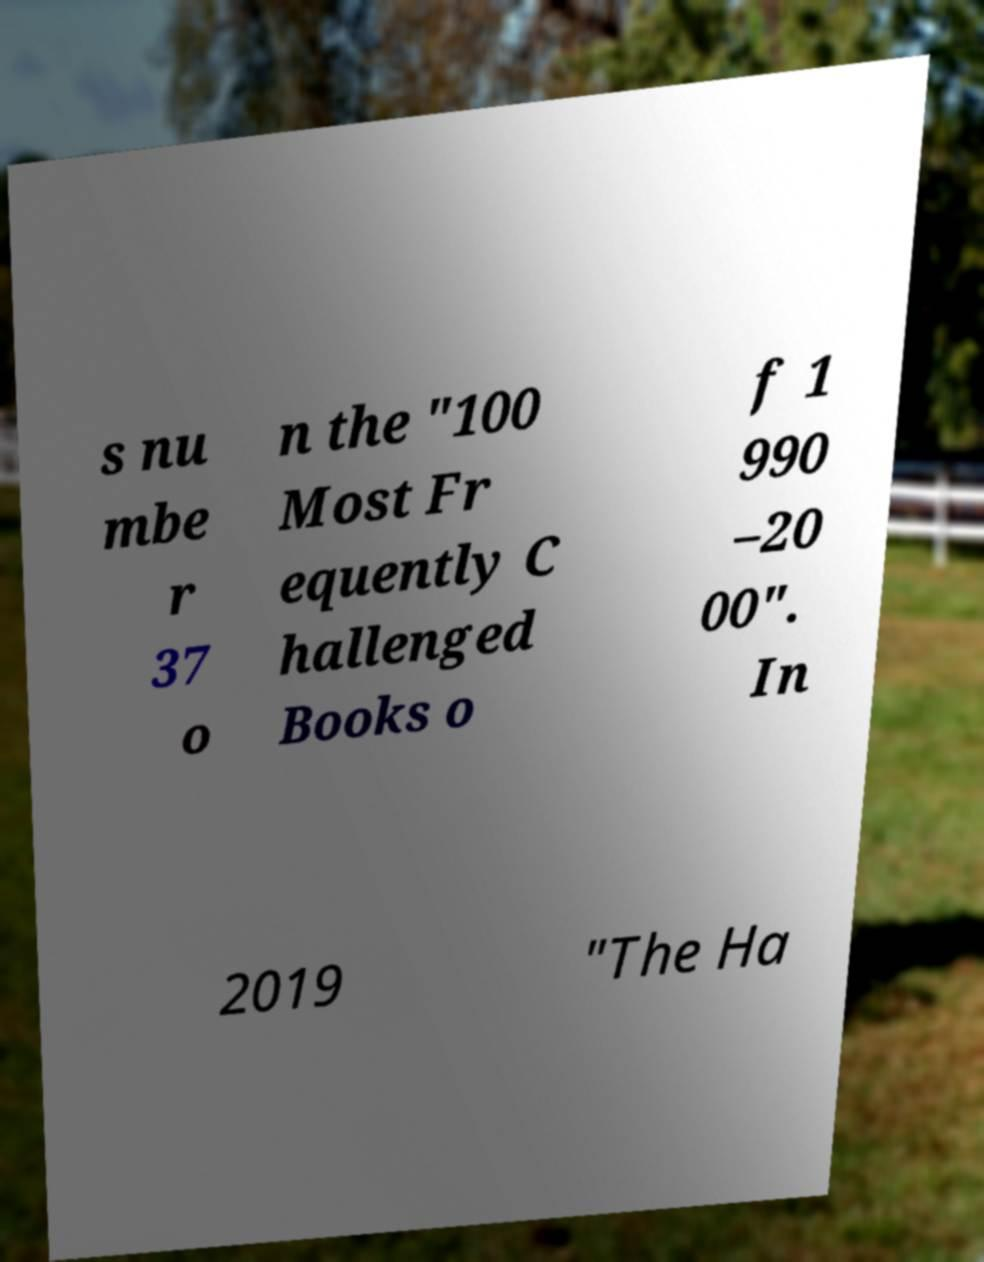Could you extract and type out the text from this image? s nu mbe r 37 o n the "100 Most Fr equently C hallenged Books o f 1 990 –20 00". In 2019 "The Ha 